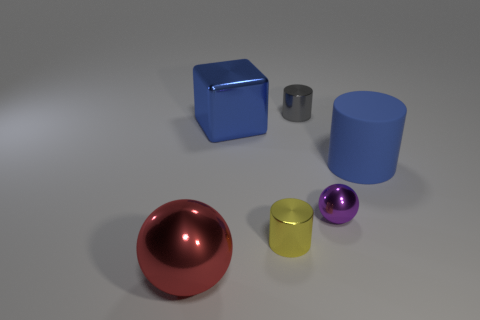Add 1 blue rubber spheres. How many objects exist? 7 Subtract all cubes. How many objects are left? 5 Add 4 shiny balls. How many shiny balls are left? 6 Add 1 tiny cylinders. How many tiny cylinders exist? 3 Subtract 0 green balls. How many objects are left? 6 Subtract all tiny shiny objects. Subtract all tiny gray cubes. How many objects are left? 3 